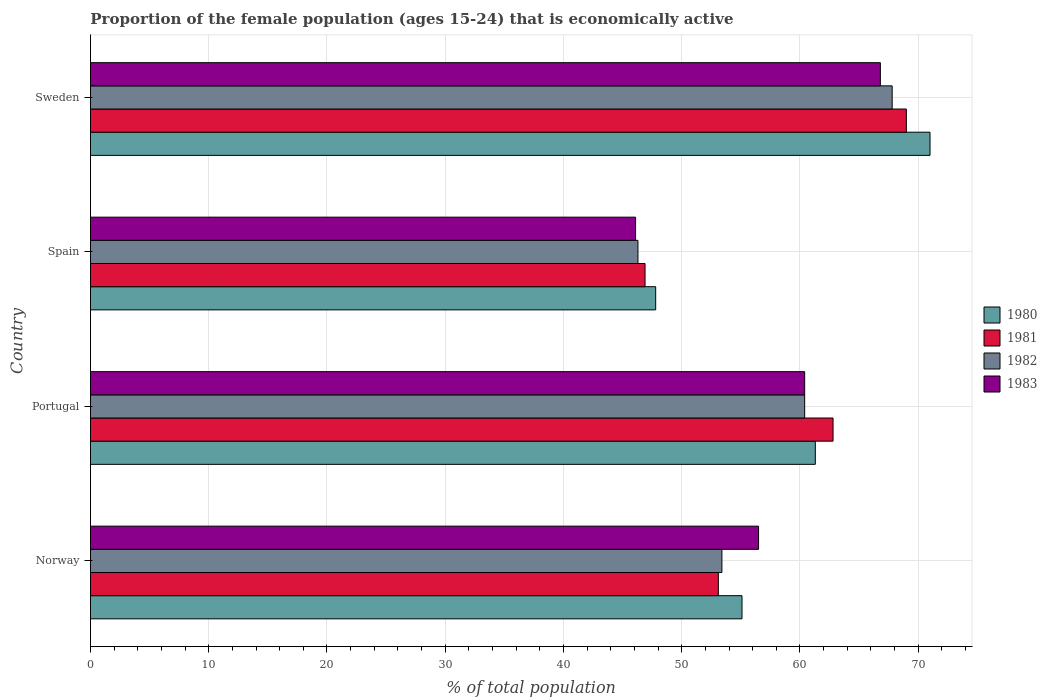How many groups of bars are there?
Your answer should be very brief. 4. Are the number of bars per tick equal to the number of legend labels?
Your response must be concise. Yes. How many bars are there on the 3rd tick from the top?
Ensure brevity in your answer.  4. How many bars are there on the 3rd tick from the bottom?
Offer a terse response. 4. In how many cases, is the number of bars for a given country not equal to the number of legend labels?
Offer a terse response. 0. What is the proportion of the female population that is economically active in 1982 in Norway?
Your response must be concise. 53.4. Across all countries, what is the maximum proportion of the female population that is economically active in 1982?
Your response must be concise. 67.8. Across all countries, what is the minimum proportion of the female population that is economically active in 1980?
Keep it short and to the point. 47.8. In which country was the proportion of the female population that is economically active in 1982 maximum?
Your answer should be compact. Sweden. What is the total proportion of the female population that is economically active in 1981 in the graph?
Your answer should be very brief. 231.8. What is the difference between the proportion of the female population that is economically active in 1982 in Norway and that in Spain?
Provide a succinct answer. 7.1. What is the difference between the proportion of the female population that is economically active in 1981 in Norway and the proportion of the female population that is economically active in 1980 in Spain?
Ensure brevity in your answer.  5.3. What is the average proportion of the female population that is economically active in 1980 per country?
Provide a short and direct response. 58.8. What is the difference between the proportion of the female population that is economically active in 1981 and proportion of the female population that is economically active in 1980 in Portugal?
Provide a short and direct response. 1.5. What is the ratio of the proportion of the female population that is economically active in 1981 in Norway to that in Portugal?
Your response must be concise. 0.85. Is the proportion of the female population that is economically active in 1981 in Portugal less than that in Spain?
Make the answer very short. No. What is the difference between the highest and the second highest proportion of the female population that is economically active in 1983?
Provide a short and direct response. 6.4. What is the difference between the highest and the lowest proportion of the female population that is economically active in 1983?
Keep it short and to the point. 20.7. In how many countries, is the proportion of the female population that is economically active in 1982 greater than the average proportion of the female population that is economically active in 1982 taken over all countries?
Provide a short and direct response. 2. Is the sum of the proportion of the female population that is economically active in 1980 in Norway and Spain greater than the maximum proportion of the female population that is economically active in 1981 across all countries?
Provide a succinct answer. Yes. What does the 1st bar from the top in Norway represents?
Keep it short and to the point. 1983. What does the 1st bar from the bottom in Spain represents?
Give a very brief answer. 1980. How many bars are there?
Offer a very short reply. 16. How many countries are there in the graph?
Your answer should be very brief. 4. Are the values on the major ticks of X-axis written in scientific E-notation?
Provide a succinct answer. No. Does the graph contain grids?
Offer a very short reply. Yes. How many legend labels are there?
Offer a terse response. 4. How are the legend labels stacked?
Keep it short and to the point. Vertical. What is the title of the graph?
Make the answer very short. Proportion of the female population (ages 15-24) that is economically active. Does "1963" appear as one of the legend labels in the graph?
Provide a succinct answer. No. What is the label or title of the X-axis?
Provide a succinct answer. % of total population. What is the label or title of the Y-axis?
Give a very brief answer. Country. What is the % of total population of 1980 in Norway?
Keep it short and to the point. 55.1. What is the % of total population in 1981 in Norway?
Offer a terse response. 53.1. What is the % of total population of 1982 in Norway?
Make the answer very short. 53.4. What is the % of total population in 1983 in Norway?
Ensure brevity in your answer.  56.5. What is the % of total population of 1980 in Portugal?
Provide a succinct answer. 61.3. What is the % of total population of 1981 in Portugal?
Provide a succinct answer. 62.8. What is the % of total population in 1982 in Portugal?
Ensure brevity in your answer.  60.4. What is the % of total population in 1983 in Portugal?
Ensure brevity in your answer.  60.4. What is the % of total population in 1980 in Spain?
Make the answer very short. 47.8. What is the % of total population of 1981 in Spain?
Your response must be concise. 46.9. What is the % of total population of 1982 in Spain?
Provide a short and direct response. 46.3. What is the % of total population in 1983 in Spain?
Ensure brevity in your answer.  46.1. What is the % of total population in 1982 in Sweden?
Your answer should be compact. 67.8. What is the % of total population in 1983 in Sweden?
Provide a short and direct response. 66.8. Across all countries, what is the maximum % of total population of 1980?
Your answer should be compact. 71. Across all countries, what is the maximum % of total population in 1981?
Offer a terse response. 69. Across all countries, what is the maximum % of total population of 1982?
Your answer should be compact. 67.8. Across all countries, what is the maximum % of total population in 1983?
Make the answer very short. 66.8. Across all countries, what is the minimum % of total population in 1980?
Offer a terse response. 47.8. Across all countries, what is the minimum % of total population of 1981?
Your answer should be compact. 46.9. Across all countries, what is the minimum % of total population of 1982?
Offer a terse response. 46.3. Across all countries, what is the minimum % of total population in 1983?
Make the answer very short. 46.1. What is the total % of total population of 1980 in the graph?
Offer a very short reply. 235.2. What is the total % of total population in 1981 in the graph?
Your answer should be very brief. 231.8. What is the total % of total population in 1982 in the graph?
Your answer should be very brief. 227.9. What is the total % of total population of 1983 in the graph?
Ensure brevity in your answer.  229.8. What is the difference between the % of total population of 1980 in Norway and that in Portugal?
Provide a succinct answer. -6.2. What is the difference between the % of total population in 1981 in Norway and that in Portugal?
Ensure brevity in your answer.  -9.7. What is the difference between the % of total population of 1982 in Norway and that in Portugal?
Provide a short and direct response. -7. What is the difference between the % of total population in 1981 in Norway and that in Spain?
Your answer should be very brief. 6.2. What is the difference between the % of total population in 1983 in Norway and that in Spain?
Provide a succinct answer. 10.4. What is the difference between the % of total population of 1980 in Norway and that in Sweden?
Keep it short and to the point. -15.9. What is the difference between the % of total population in 1981 in Norway and that in Sweden?
Offer a terse response. -15.9. What is the difference between the % of total population of 1982 in Norway and that in Sweden?
Ensure brevity in your answer.  -14.4. What is the difference between the % of total population in 1982 in Portugal and that in Spain?
Your answer should be compact. 14.1. What is the difference between the % of total population in 1983 in Portugal and that in Spain?
Provide a short and direct response. 14.3. What is the difference between the % of total population of 1980 in Spain and that in Sweden?
Ensure brevity in your answer.  -23.2. What is the difference between the % of total population of 1981 in Spain and that in Sweden?
Keep it short and to the point. -22.1. What is the difference between the % of total population in 1982 in Spain and that in Sweden?
Offer a terse response. -21.5. What is the difference between the % of total population of 1983 in Spain and that in Sweden?
Provide a short and direct response. -20.7. What is the difference between the % of total population of 1980 in Norway and the % of total population of 1982 in Portugal?
Give a very brief answer. -5.3. What is the difference between the % of total population in 1980 in Norway and the % of total population in 1983 in Portugal?
Your answer should be compact. -5.3. What is the difference between the % of total population of 1981 in Norway and the % of total population of 1982 in Portugal?
Make the answer very short. -7.3. What is the difference between the % of total population of 1982 in Norway and the % of total population of 1983 in Portugal?
Your answer should be compact. -7. What is the difference between the % of total population of 1980 in Norway and the % of total population of 1981 in Spain?
Keep it short and to the point. 8.2. What is the difference between the % of total population of 1982 in Norway and the % of total population of 1983 in Spain?
Your response must be concise. 7.3. What is the difference between the % of total population of 1980 in Norway and the % of total population of 1981 in Sweden?
Provide a short and direct response. -13.9. What is the difference between the % of total population of 1980 in Norway and the % of total population of 1982 in Sweden?
Keep it short and to the point. -12.7. What is the difference between the % of total population of 1980 in Norway and the % of total population of 1983 in Sweden?
Provide a short and direct response. -11.7. What is the difference between the % of total population of 1981 in Norway and the % of total population of 1982 in Sweden?
Make the answer very short. -14.7. What is the difference between the % of total population in 1981 in Norway and the % of total population in 1983 in Sweden?
Provide a succinct answer. -13.7. What is the difference between the % of total population of 1980 in Portugal and the % of total population of 1981 in Spain?
Provide a short and direct response. 14.4. What is the difference between the % of total population in 1980 in Portugal and the % of total population in 1983 in Spain?
Give a very brief answer. 15.2. What is the difference between the % of total population in 1981 in Portugal and the % of total population in 1983 in Spain?
Keep it short and to the point. 16.7. What is the difference between the % of total population of 1982 in Portugal and the % of total population of 1983 in Spain?
Keep it short and to the point. 14.3. What is the difference between the % of total population of 1980 in Portugal and the % of total population of 1982 in Sweden?
Your response must be concise. -6.5. What is the difference between the % of total population in 1980 in Portugal and the % of total population in 1983 in Sweden?
Your response must be concise. -5.5. What is the difference between the % of total population of 1980 in Spain and the % of total population of 1981 in Sweden?
Provide a succinct answer. -21.2. What is the difference between the % of total population of 1980 in Spain and the % of total population of 1982 in Sweden?
Ensure brevity in your answer.  -20. What is the difference between the % of total population in 1980 in Spain and the % of total population in 1983 in Sweden?
Provide a short and direct response. -19. What is the difference between the % of total population of 1981 in Spain and the % of total population of 1982 in Sweden?
Offer a very short reply. -20.9. What is the difference between the % of total population in 1981 in Spain and the % of total population in 1983 in Sweden?
Provide a succinct answer. -19.9. What is the difference between the % of total population of 1982 in Spain and the % of total population of 1983 in Sweden?
Your response must be concise. -20.5. What is the average % of total population in 1980 per country?
Your response must be concise. 58.8. What is the average % of total population in 1981 per country?
Keep it short and to the point. 57.95. What is the average % of total population in 1982 per country?
Give a very brief answer. 56.98. What is the average % of total population of 1983 per country?
Your answer should be very brief. 57.45. What is the difference between the % of total population of 1980 and % of total population of 1982 in Norway?
Make the answer very short. 1.7. What is the difference between the % of total population of 1981 and % of total population of 1982 in Norway?
Provide a short and direct response. -0.3. What is the difference between the % of total population of 1981 and % of total population of 1983 in Norway?
Give a very brief answer. -3.4. What is the difference between the % of total population of 1980 and % of total population of 1982 in Portugal?
Provide a short and direct response. 0.9. What is the difference between the % of total population of 1980 and % of total population of 1983 in Portugal?
Offer a very short reply. 0.9. What is the difference between the % of total population of 1981 and % of total population of 1982 in Portugal?
Make the answer very short. 2.4. What is the difference between the % of total population of 1981 and % of total population of 1983 in Portugal?
Offer a very short reply. 2.4. What is the difference between the % of total population of 1980 and % of total population of 1983 in Spain?
Offer a very short reply. 1.7. What is the difference between the % of total population in 1981 and % of total population in 1983 in Spain?
Keep it short and to the point. 0.8. What is the difference between the % of total population of 1980 and % of total population of 1983 in Sweden?
Provide a short and direct response. 4.2. What is the difference between the % of total population of 1981 and % of total population of 1982 in Sweden?
Make the answer very short. 1.2. What is the difference between the % of total population of 1981 and % of total population of 1983 in Sweden?
Keep it short and to the point. 2.2. What is the ratio of the % of total population in 1980 in Norway to that in Portugal?
Provide a short and direct response. 0.9. What is the ratio of the % of total population of 1981 in Norway to that in Portugal?
Your answer should be very brief. 0.85. What is the ratio of the % of total population in 1982 in Norway to that in Portugal?
Provide a short and direct response. 0.88. What is the ratio of the % of total population in 1983 in Norway to that in Portugal?
Your answer should be compact. 0.94. What is the ratio of the % of total population in 1980 in Norway to that in Spain?
Your answer should be compact. 1.15. What is the ratio of the % of total population of 1981 in Norway to that in Spain?
Give a very brief answer. 1.13. What is the ratio of the % of total population in 1982 in Norway to that in Spain?
Offer a terse response. 1.15. What is the ratio of the % of total population of 1983 in Norway to that in Spain?
Provide a short and direct response. 1.23. What is the ratio of the % of total population in 1980 in Norway to that in Sweden?
Ensure brevity in your answer.  0.78. What is the ratio of the % of total population in 1981 in Norway to that in Sweden?
Offer a very short reply. 0.77. What is the ratio of the % of total population of 1982 in Norway to that in Sweden?
Make the answer very short. 0.79. What is the ratio of the % of total population of 1983 in Norway to that in Sweden?
Your response must be concise. 0.85. What is the ratio of the % of total population of 1980 in Portugal to that in Spain?
Provide a short and direct response. 1.28. What is the ratio of the % of total population of 1981 in Portugal to that in Spain?
Your answer should be very brief. 1.34. What is the ratio of the % of total population in 1982 in Portugal to that in Spain?
Provide a short and direct response. 1.3. What is the ratio of the % of total population of 1983 in Portugal to that in Spain?
Provide a succinct answer. 1.31. What is the ratio of the % of total population in 1980 in Portugal to that in Sweden?
Keep it short and to the point. 0.86. What is the ratio of the % of total population of 1981 in Portugal to that in Sweden?
Your answer should be very brief. 0.91. What is the ratio of the % of total population in 1982 in Portugal to that in Sweden?
Provide a short and direct response. 0.89. What is the ratio of the % of total population of 1983 in Portugal to that in Sweden?
Give a very brief answer. 0.9. What is the ratio of the % of total population in 1980 in Spain to that in Sweden?
Keep it short and to the point. 0.67. What is the ratio of the % of total population in 1981 in Spain to that in Sweden?
Provide a short and direct response. 0.68. What is the ratio of the % of total population in 1982 in Spain to that in Sweden?
Offer a terse response. 0.68. What is the ratio of the % of total population of 1983 in Spain to that in Sweden?
Make the answer very short. 0.69. What is the difference between the highest and the second highest % of total population of 1980?
Keep it short and to the point. 9.7. What is the difference between the highest and the lowest % of total population in 1980?
Keep it short and to the point. 23.2. What is the difference between the highest and the lowest % of total population in 1981?
Your answer should be very brief. 22.1. What is the difference between the highest and the lowest % of total population of 1982?
Your response must be concise. 21.5. What is the difference between the highest and the lowest % of total population in 1983?
Provide a short and direct response. 20.7. 